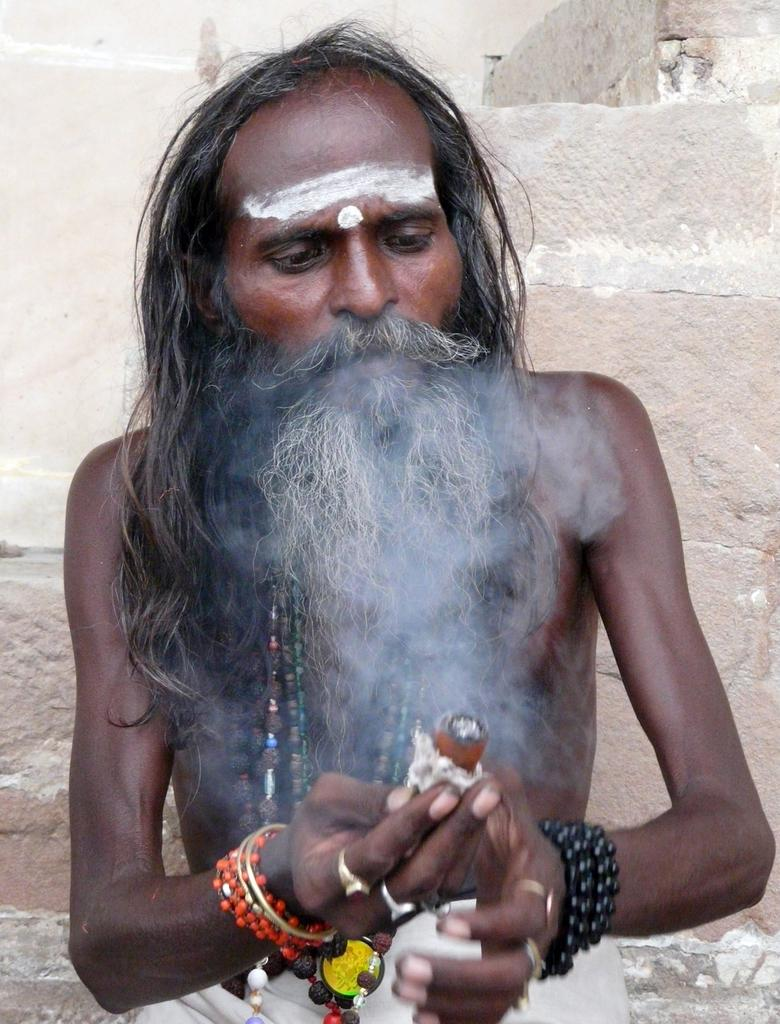What can be observed about the person in the image? There is a person with a beard in the image. What is the person holding in the image? The person is holding an object. What can be seen in the background of the image? There is a wall in the background of the image. How many clocks can be seen on the wall in the image? There are no clocks visible on the wall in the image. What type of zephyr is present in the image? There is no zephyr present in the image. 